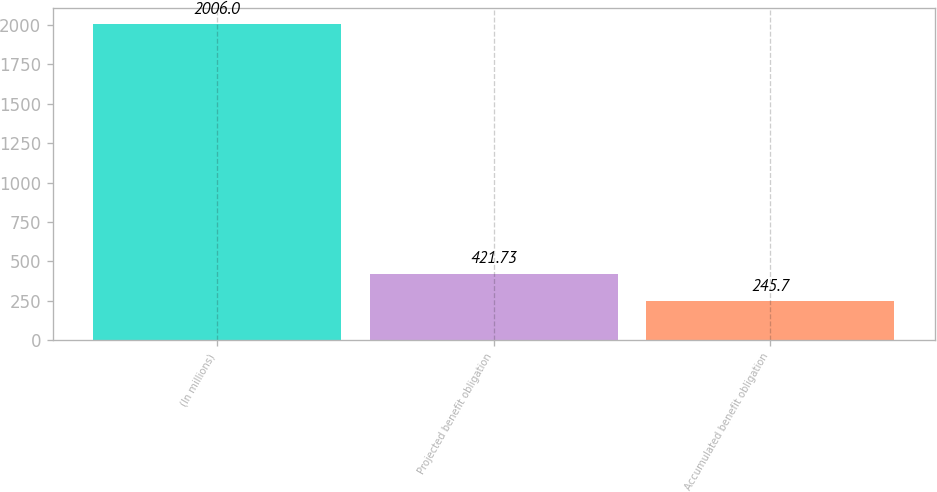Convert chart. <chart><loc_0><loc_0><loc_500><loc_500><bar_chart><fcel>(In millions)<fcel>Projected benefit obligation<fcel>Accumulated benefit obligation<nl><fcel>2006<fcel>421.73<fcel>245.7<nl></chart> 